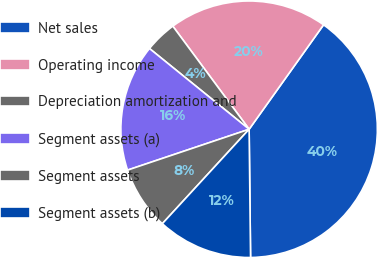Convert chart. <chart><loc_0><loc_0><loc_500><loc_500><pie_chart><fcel>Net sales<fcel>Operating income<fcel>Depreciation amortization and<fcel>Segment assets (a)<fcel>Segment assets<fcel>Segment assets (b)<nl><fcel>39.97%<fcel>20.0%<fcel>4.02%<fcel>16.0%<fcel>8.01%<fcel>12.01%<nl></chart> 